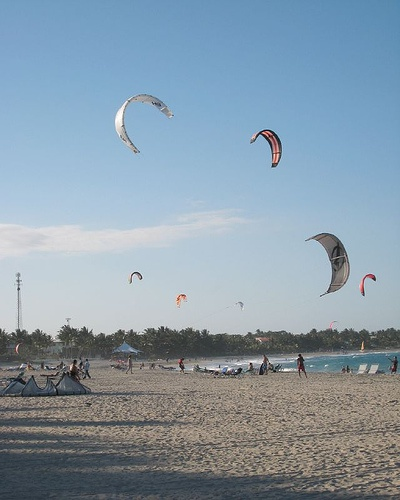Describe the objects in this image and their specific colors. I can see people in darkgray and gray tones, kite in darkgray, lightblue, lightgray, and gray tones, kite in darkgray, gray, and black tones, kite in darkgray, black, brown, and gray tones, and kite in darkgray, lightblue, and brown tones in this image. 